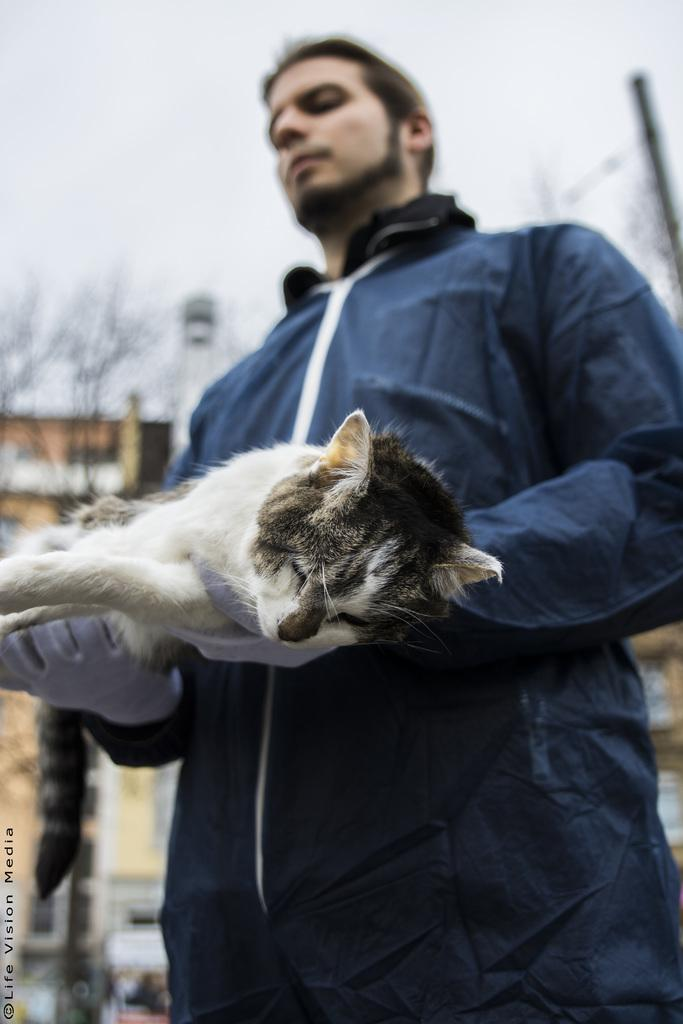Who is present in the image? There is a man in the image. What is the man wearing? The man is wearing a blue suit. What is the man holding in the image? The man is holding a cat. What can be seen in the background of the image? There is a building and trees in the background of the image. What type of quill is the man using to write on the volleyball in the image? There is no quill or volleyball present in the image. The man is holding a cat, not a quill or volleyball. 